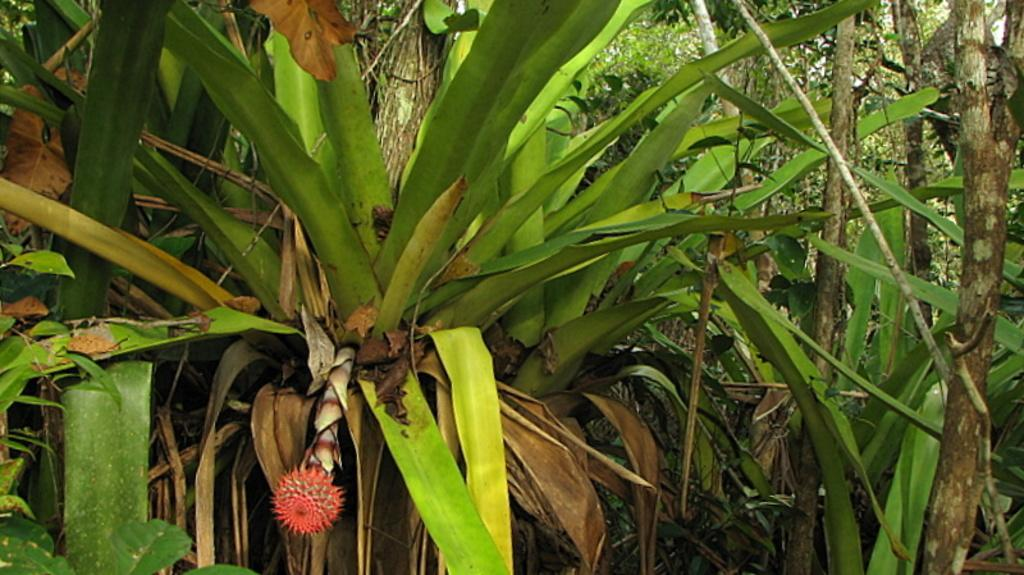What type of vegetation can be seen in the image? There are plants and trees in the image. Can you describe the location of the flower in the image? The flower is present on the left bottom side of the image. Where is the map located in the image? There is no map present in the image. What type of crack can be seen on the tree trunk in the image? There is no tree trunk or crack visible in the image. 